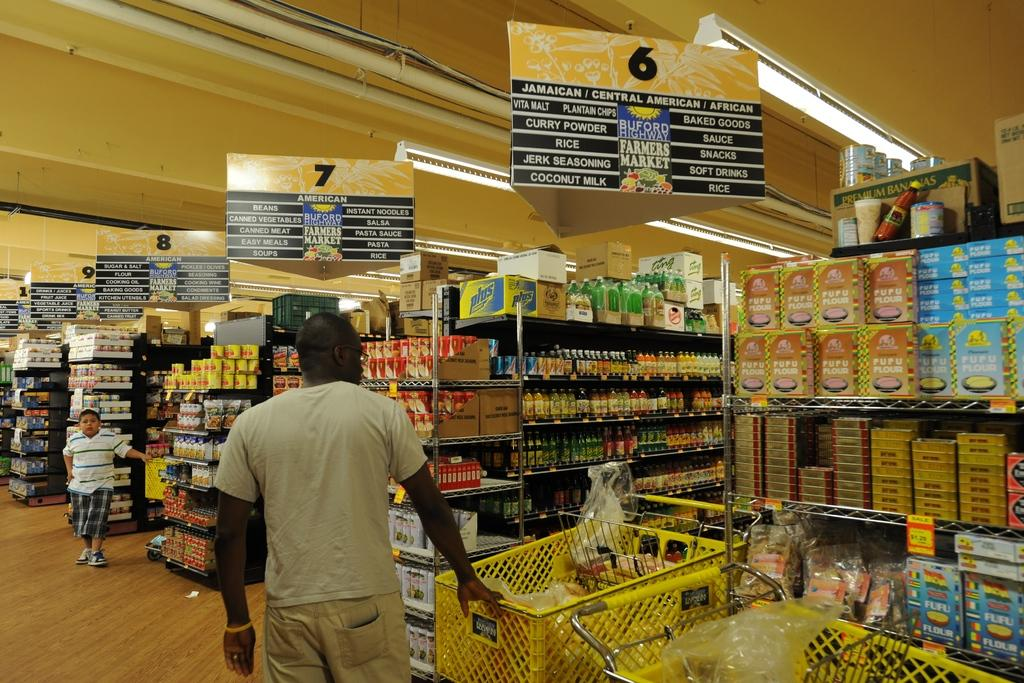<image>
Provide a brief description of the given image. A man standing in a grocery store under aisle 6 which contains baked goods. 